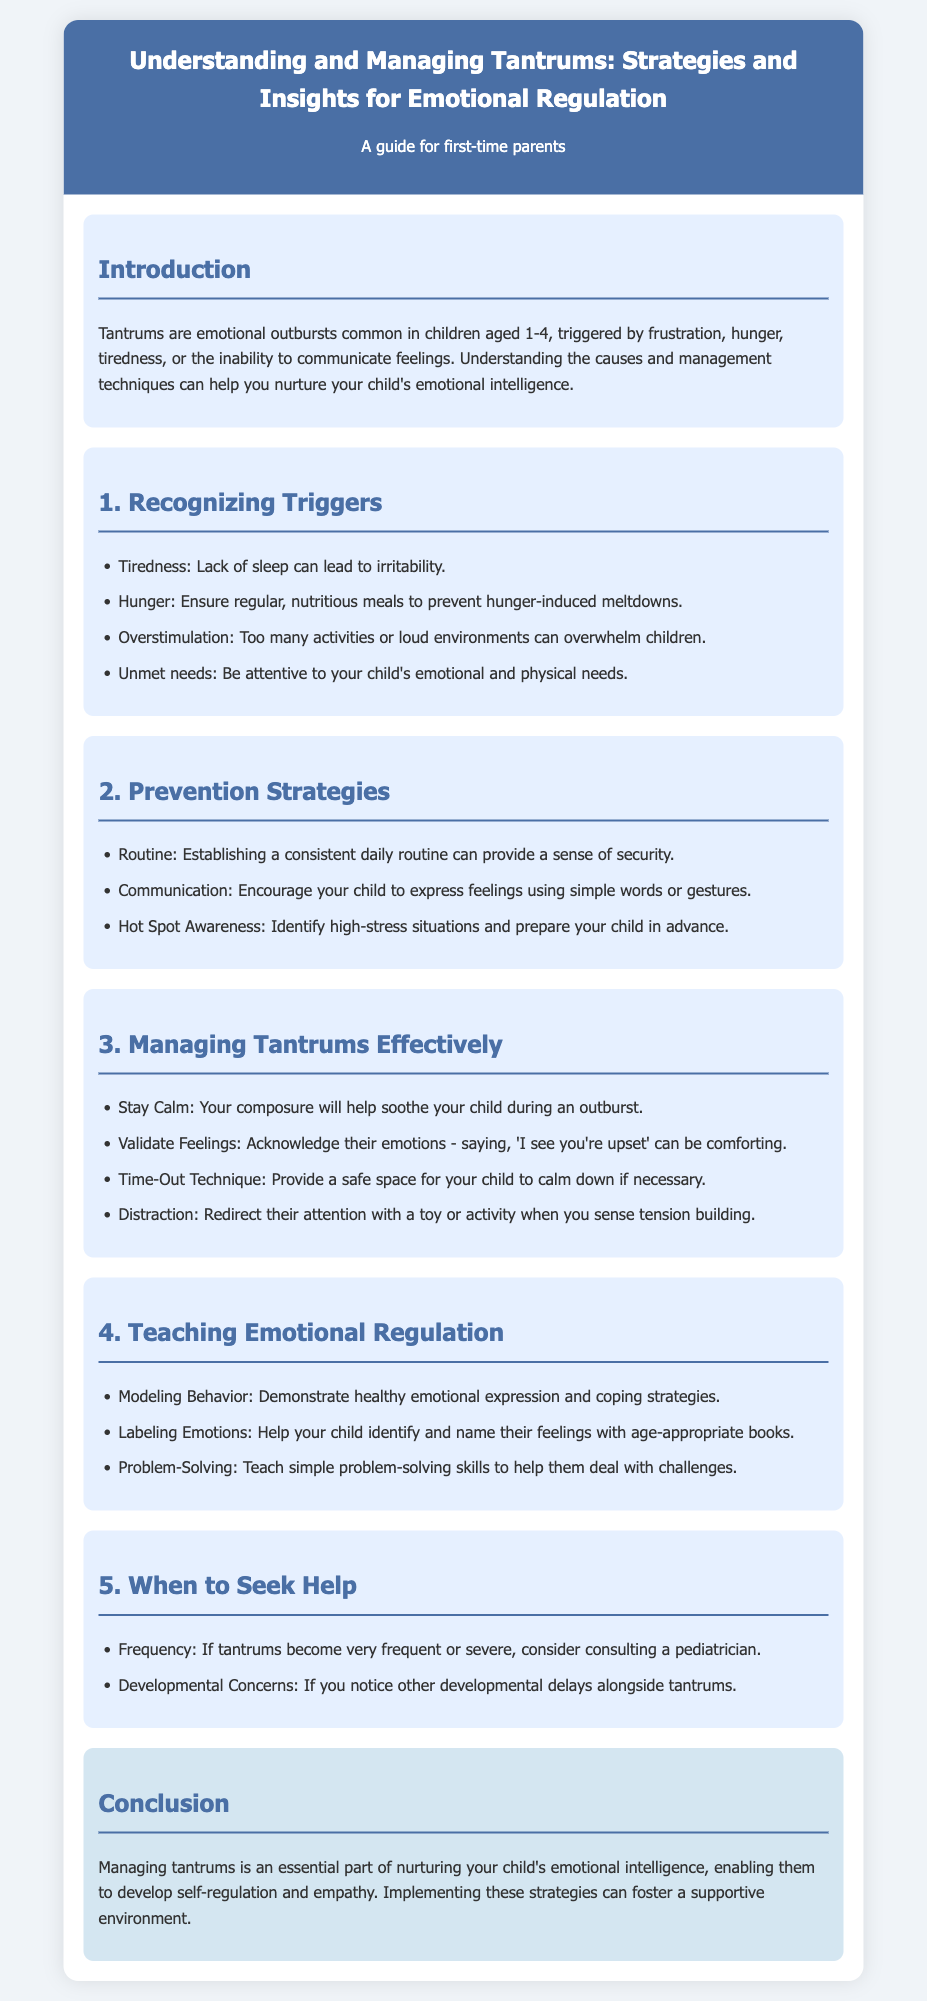What age range do tantrums typically occur? The document states that tantrums are common in children aged 1-4.
Answer: 1-4 What is one common trigger for tantrums? The document lists tiredness, hunger, overstimulation, and unmet needs as common triggers.
Answer: Tiredness What is a recommended strategy for preventing tantrums? The document suggests establishing a consistent daily routine as a preventive measure.
Answer: Routine What should parents do during a tantrum? According to the document, parents should stay calm during a child's tantrum.
Answer: Stay Calm When should parents consider seeking help? The document advises consulting a pediatrician if tantrums become very frequent or severe.
Answer: Very frequent or severe What is one way to teach emotional regulation? The document advises modeling behavior as a way to teach emotional regulation.
Answer: Modeling Behavior What is the focus of the conclusion? The conclusion emphasizes the importance of managing tantrums to nurture emotional intelligence.
Answer: Nurturing emotional intelligence What does "Hot Spot Awareness" refer to? The document suggests it involves identifying high-stress situations and preparing the child in advance.
Answer: Identifying high-stress situations 